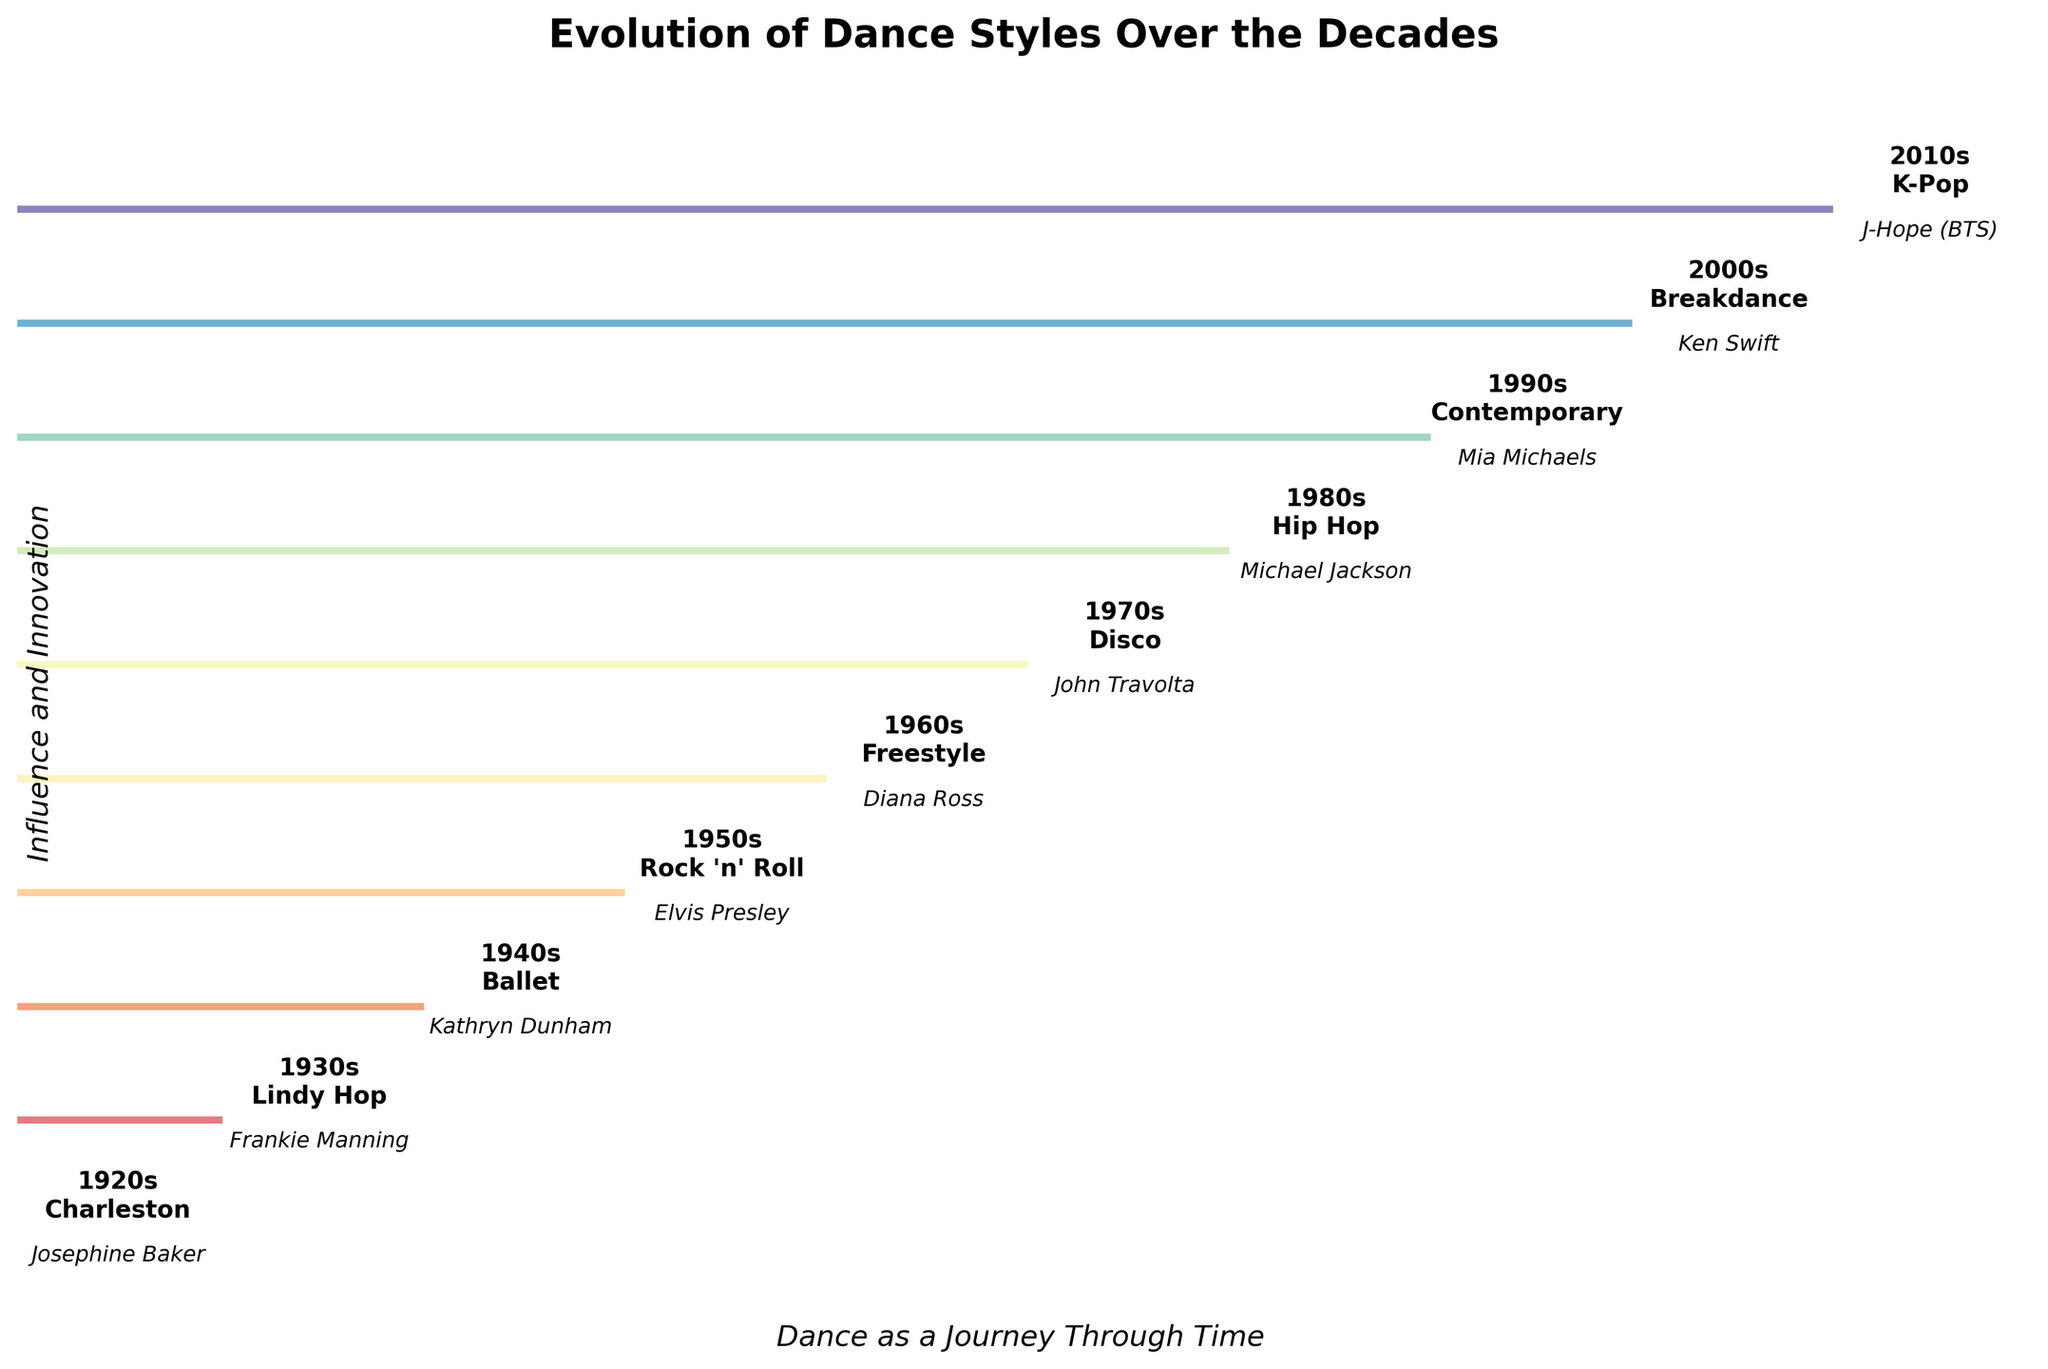When was the Charleston dance style prominently popularized? Look at the step corresponding to "Charleston" on the plot, which is labeled with the decade.
Answer: 1920s Who was the major contributor to the dance style in the 1980s? Find the information under the 1980s label.
Answer: Michael Jackson What is the title of the figure? The title is written at the top of the figure.
Answer: Evolution of Dance Styles Over the Decades If we average the decades with the dance styles Ballet and Disco, what decade do we get? Ballet is in the 1940s, Disco is in the 1970s. The average is (1940 + 1970) / 2.
Answer: 1955 Which contributor in the figure has had a notable influence on Motown choreography? Check the labels for noted influences on each contributor.
Answer: Diana Ross What influence did Michael Jackson have on Hip Hop? Refer to the influence text associated with Michael Jackson.
Answer: Global influence with "Moonwalk" How many dance styles are shown in the 20th century? Count the styles listed from 1920s to 1990s.
Answer: 8 Which dance styles were influential in the media, specifically mentioning Broadway and films? Look for the contributions that specifically mention Broadway and films.
Answer: Charleston Compare the influences between the 1950s and 1970s contributors. Look at the influence text for the contributors in the 1950s (Elvis Presley) and 1970s (John Travolta).
Answer: Elvis Presley innovated stage performance with dance; John Travolta made Disco popular through "Saturday Night Fever" Which decade shows integration of complex choreography in pop music? Find the decade associated with K-Pop as described in the influence text.
Answer: 2010s 